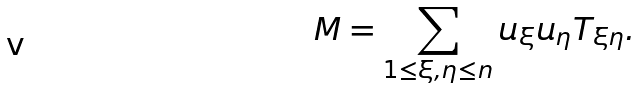Convert formula to latex. <formula><loc_0><loc_0><loc_500><loc_500>M = \sum _ { 1 \leq \xi , \eta \leq n } u _ { \xi } u _ { \eta } T _ { \xi \eta } .</formula> 